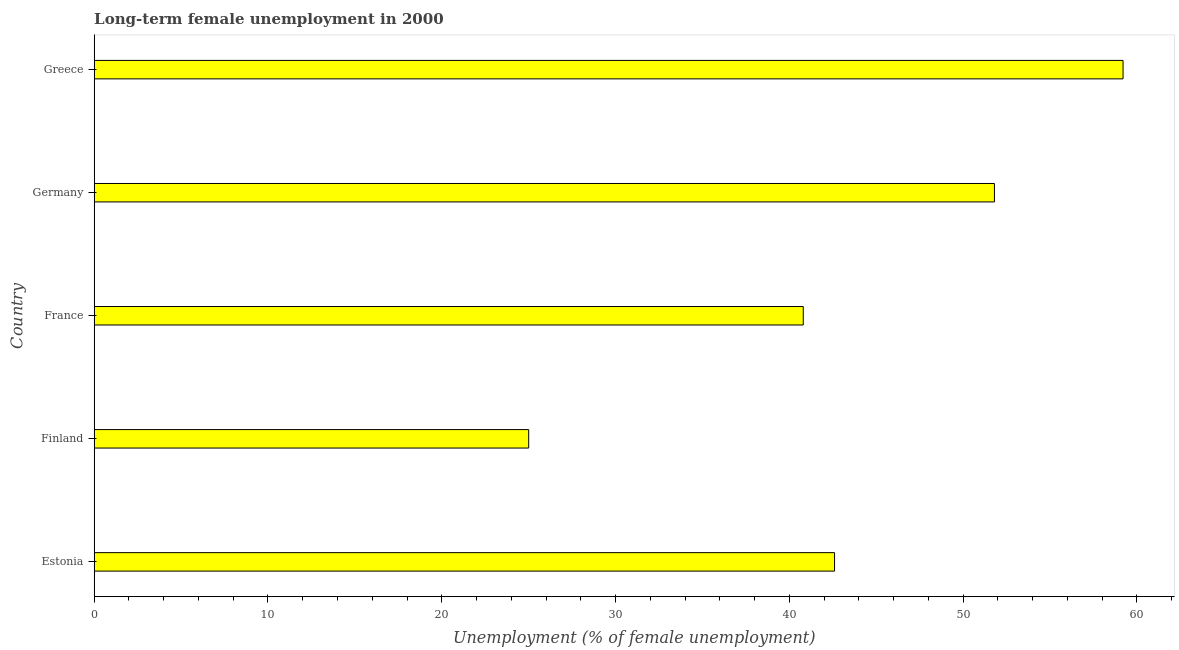Does the graph contain any zero values?
Ensure brevity in your answer.  No. Does the graph contain grids?
Provide a short and direct response. No. What is the title of the graph?
Ensure brevity in your answer.  Long-term female unemployment in 2000. What is the label or title of the X-axis?
Offer a very short reply. Unemployment (% of female unemployment). What is the label or title of the Y-axis?
Give a very brief answer. Country. What is the long-term female unemployment in Estonia?
Provide a short and direct response. 42.6. Across all countries, what is the maximum long-term female unemployment?
Your answer should be very brief. 59.2. Across all countries, what is the minimum long-term female unemployment?
Your answer should be compact. 25. In which country was the long-term female unemployment maximum?
Provide a succinct answer. Greece. What is the sum of the long-term female unemployment?
Your answer should be compact. 219.4. What is the difference between the long-term female unemployment in Finland and France?
Provide a short and direct response. -15.8. What is the average long-term female unemployment per country?
Ensure brevity in your answer.  43.88. What is the median long-term female unemployment?
Your answer should be compact. 42.6. In how many countries, is the long-term female unemployment greater than 10 %?
Give a very brief answer. 5. What is the ratio of the long-term female unemployment in Finland to that in Germany?
Your answer should be very brief. 0.48. Is the long-term female unemployment in Finland less than that in Greece?
Provide a short and direct response. Yes. Is the difference between the long-term female unemployment in Finland and France greater than the difference between any two countries?
Your answer should be very brief. No. What is the difference between the highest and the second highest long-term female unemployment?
Provide a succinct answer. 7.4. Is the sum of the long-term female unemployment in France and Germany greater than the maximum long-term female unemployment across all countries?
Offer a very short reply. Yes. What is the difference between the highest and the lowest long-term female unemployment?
Provide a short and direct response. 34.2. Are the values on the major ticks of X-axis written in scientific E-notation?
Give a very brief answer. No. What is the Unemployment (% of female unemployment) of Estonia?
Offer a very short reply. 42.6. What is the Unemployment (% of female unemployment) of Finland?
Ensure brevity in your answer.  25. What is the Unemployment (% of female unemployment) of France?
Provide a succinct answer. 40.8. What is the Unemployment (% of female unemployment) of Germany?
Ensure brevity in your answer.  51.8. What is the Unemployment (% of female unemployment) in Greece?
Your answer should be very brief. 59.2. What is the difference between the Unemployment (% of female unemployment) in Estonia and France?
Your answer should be compact. 1.8. What is the difference between the Unemployment (% of female unemployment) in Estonia and Greece?
Your response must be concise. -16.6. What is the difference between the Unemployment (% of female unemployment) in Finland and France?
Provide a short and direct response. -15.8. What is the difference between the Unemployment (% of female unemployment) in Finland and Germany?
Your answer should be very brief. -26.8. What is the difference between the Unemployment (% of female unemployment) in Finland and Greece?
Keep it short and to the point. -34.2. What is the difference between the Unemployment (% of female unemployment) in France and Germany?
Provide a short and direct response. -11. What is the difference between the Unemployment (% of female unemployment) in France and Greece?
Offer a terse response. -18.4. What is the difference between the Unemployment (% of female unemployment) in Germany and Greece?
Your response must be concise. -7.4. What is the ratio of the Unemployment (% of female unemployment) in Estonia to that in Finland?
Offer a very short reply. 1.7. What is the ratio of the Unemployment (% of female unemployment) in Estonia to that in France?
Ensure brevity in your answer.  1.04. What is the ratio of the Unemployment (% of female unemployment) in Estonia to that in Germany?
Offer a terse response. 0.82. What is the ratio of the Unemployment (% of female unemployment) in Estonia to that in Greece?
Provide a short and direct response. 0.72. What is the ratio of the Unemployment (% of female unemployment) in Finland to that in France?
Provide a succinct answer. 0.61. What is the ratio of the Unemployment (% of female unemployment) in Finland to that in Germany?
Give a very brief answer. 0.48. What is the ratio of the Unemployment (% of female unemployment) in Finland to that in Greece?
Ensure brevity in your answer.  0.42. What is the ratio of the Unemployment (% of female unemployment) in France to that in Germany?
Your answer should be compact. 0.79. What is the ratio of the Unemployment (% of female unemployment) in France to that in Greece?
Provide a short and direct response. 0.69. What is the ratio of the Unemployment (% of female unemployment) in Germany to that in Greece?
Provide a succinct answer. 0.88. 